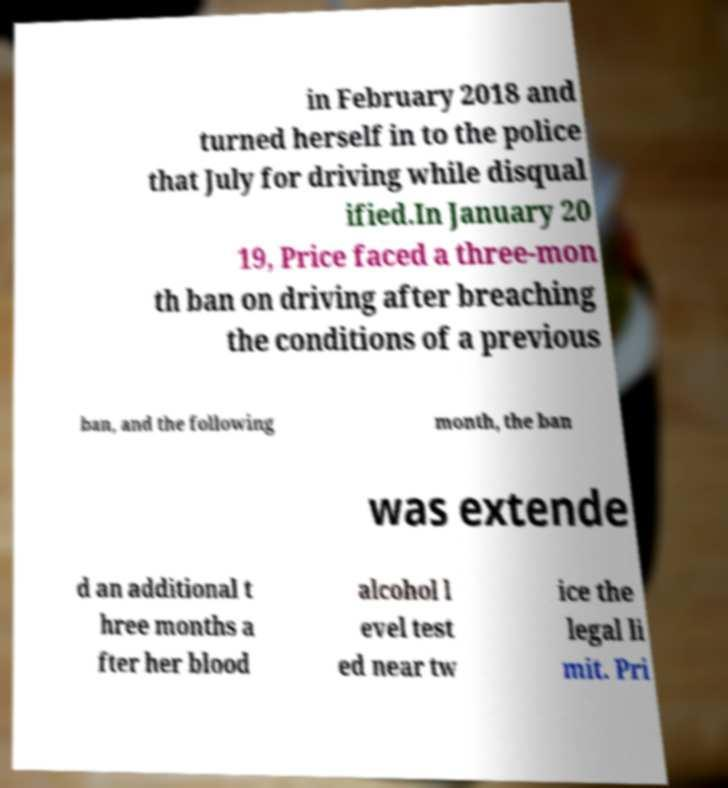For documentation purposes, I need the text within this image transcribed. Could you provide that? in February 2018 and turned herself in to the police that July for driving while disqual ified.In January 20 19, Price faced a three-mon th ban on driving after breaching the conditions of a previous ban, and the following month, the ban was extende d an additional t hree months a fter her blood alcohol l evel test ed near tw ice the legal li mit. Pri 